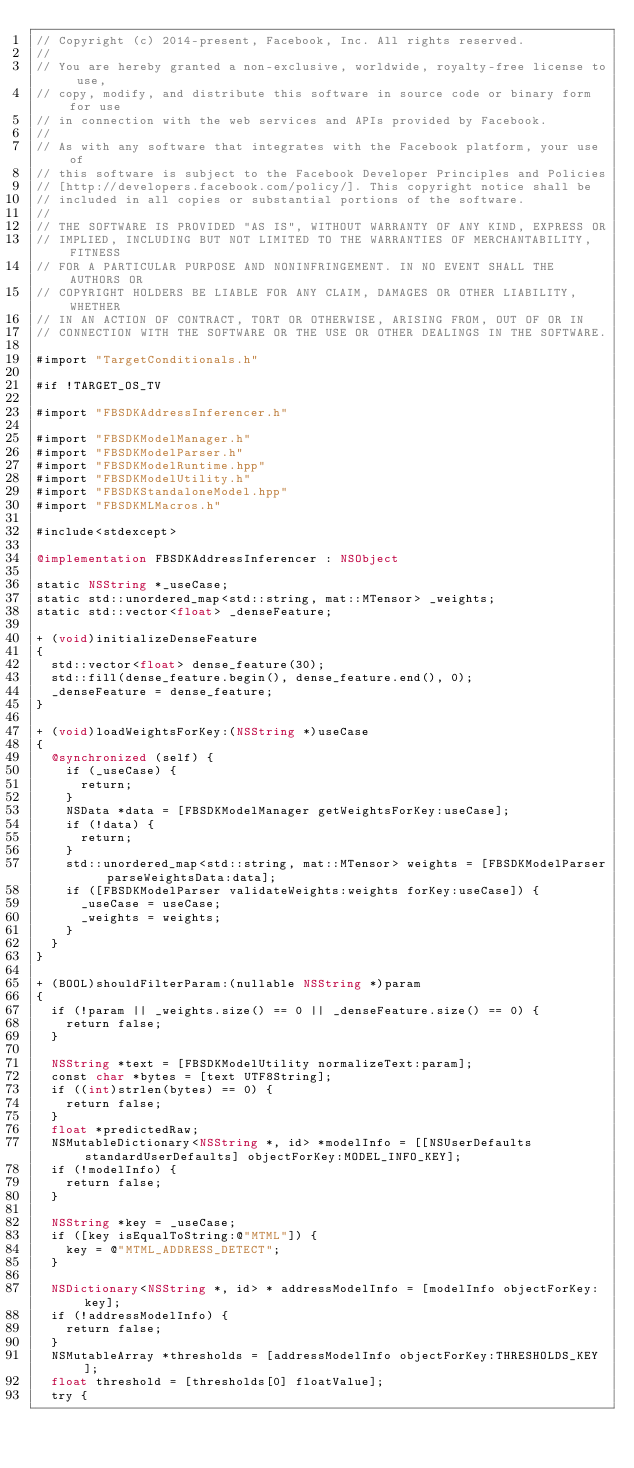Convert code to text. <code><loc_0><loc_0><loc_500><loc_500><_ObjectiveC_>// Copyright (c) 2014-present, Facebook, Inc. All rights reserved.
//
// You are hereby granted a non-exclusive, worldwide, royalty-free license to use,
// copy, modify, and distribute this software in source code or binary form for use
// in connection with the web services and APIs provided by Facebook.
//
// As with any software that integrates with the Facebook platform, your use of
// this software is subject to the Facebook Developer Principles and Policies
// [http://developers.facebook.com/policy/]. This copyright notice shall be
// included in all copies or substantial portions of the software.
//
// THE SOFTWARE IS PROVIDED "AS IS", WITHOUT WARRANTY OF ANY KIND, EXPRESS OR
// IMPLIED, INCLUDING BUT NOT LIMITED TO THE WARRANTIES OF MERCHANTABILITY, FITNESS
// FOR A PARTICULAR PURPOSE AND NONINFRINGEMENT. IN NO EVENT SHALL THE AUTHORS OR
// COPYRIGHT HOLDERS BE LIABLE FOR ANY CLAIM, DAMAGES OR OTHER LIABILITY, WHETHER
// IN AN ACTION OF CONTRACT, TORT OR OTHERWISE, ARISING FROM, OUT OF OR IN
// CONNECTION WITH THE SOFTWARE OR THE USE OR OTHER DEALINGS IN THE SOFTWARE.

#import "TargetConditionals.h"

#if !TARGET_OS_TV

#import "FBSDKAddressInferencer.h"

#import "FBSDKModelManager.h"
#import "FBSDKModelParser.h"
#import "FBSDKModelRuntime.hpp"
#import "FBSDKModelUtility.h"
#import "FBSDKStandaloneModel.hpp"
#import "FBSDKMLMacros.h"

#include<stdexcept>

@implementation FBSDKAddressInferencer : NSObject

static NSString *_useCase;
static std::unordered_map<std::string, mat::MTensor> _weights;
static std::vector<float> _denseFeature;

+ (void)initializeDenseFeature
{
  std::vector<float> dense_feature(30);
  std::fill(dense_feature.begin(), dense_feature.end(), 0);
  _denseFeature = dense_feature;
}

+ (void)loadWeightsForKey:(NSString *)useCase
{
  @synchronized (self) {
    if (_useCase) {
      return;
    }
    NSData *data = [FBSDKModelManager getWeightsForKey:useCase];
    if (!data) {
      return;
    }
    std::unordered_map<std::string, mat::MTensor> weights = [FBSDKModelParser parseWeightsData:data];
    if ([FBSDKModelParser validateWeights:weights forKey:useCase]) {
      _useCase = useCase;
      _weights = weights;
    }
  }
}

+ (BOOL)shouldFilterParam:(nullable NSString *)param
{
  if (!param || _weights.size() == 0 || _denseFeature.size() == 0) {
    return false;
  }

  NSString *text = [FBSDKModelUtility normalizeText:param];
  const char *bytes = [text UTF8String];
  if ((int)strlen(bytes) == 0) {
    return false;
  }
  float *predictedRaw;
  NSMutableDictionary<NSString *, id> *modelInfo = [[NSUserDefaults standardUserDefaults] objectForKey:MODEL_INFO_KEY];
  if (!modelInfo) {
    return false;
  }

  NSString *key = _useCase;
  if ([key isEqualToString:@"MTML"]) {
    key = @"MTML_ADDRESS_DETECT";
  }

  NSDictionary<NSString *, id> * addressModelInfo = [modelInfo objectForKey:key];
  if (!addressModelInfo) {
    return false;
  }
  NSMutableArray *thresholds = [addressModelInfo objectForKey:THRESHOLDS_KEY];
  float threshold = [thresholds[0] floatValue];
  try {</code> 